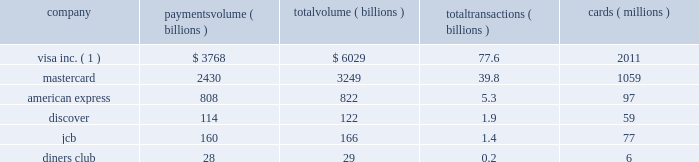As the payments landscape evolves , we may increasingly face competition from emerging players in the payment space , many of which are non-financial institution networks that have departed from the more traditional 201cbank-centric 201d business model .
The emergence of these potentially competitive networks has primarily been via the online channel with a focus on ecommerce and/or mobile technologies .
Paypal , google and isis are examples .
These providers compete with visa directly in some cases , yet may also be significant partners and customers of visa .
Based on payments volume , total volume and number of transactions , visa is the largest retail electronic payments network in the world .
The following chart compares our network with those of our major general purpose payment network competitors for calendar year 2011 : company payments volume volume transactions cards ( billions ) ( billions ) ( billions ) ( millions ) visa inc. ( 1 ) .
$ 3768 $ 6029 77.6 2011 .
( 1 ) visa inc .
Figures as reported on form 8-k filed with the sec on february 8 and may 2 , 2012 , respectively .
Visa figures represent total volume , payments volume and cash volume , and the number of payments transactions , cash transactions , accounts and cards for products carrying the visa , visa electron and interlink brands .
Card counts include plus proprietary cards .
Payments volume represents the aggregate dollar amount of purchases made with cards carrying the visa , visa electron and interlink brands for the relevant period .
Total volume represents payments volume plus cash volume .
The data presented is reported quarterly by visa 2019s clients on their operating certificates and is subject to verification by visa .
On occasion , clients may update previously submitted information .
Sources : mastercard , american express , jcb and diners club data sourced from the nilson report issue 992 ( april 2012 ) .
Includes all consumer and commercial credit , debit and prepaid cards .
Some prior year figures have been restated .
Currency figures are in u.s .
Dollars .
Mastercard excludes maestro and cirrus figures .
American express includes figures for third-party issuers .
Jcb figures include third-party issuers and other payment-related products .
Some figures are estimates .
Diners club figures are for the 12 months ended november 30 , 2011 .
Discover data sourced from the nilson report issue 986 ( january 2012 ) 2014u.s .
Data only and includes business from third-party issuers .
For more information on the concentration of our operating revenues and other financial information , see item 8 2014financial statements and supplementary data 2014note 14 2014enterprise-wide disclosures and concentration of business included elsewhere in this report .
Working capital requirements payments settlement due from and due to issuing and acquiring clients represents a substantial daily working capital requirement .
U.s .
Dollar settlements are typically settled within the same day and do not result in a receivable or payable balance , while settlement currencies other than the u.s .
Dollar generally remain outstanding for one to two business days , consistent with industry practice for such transactions. .
What is the average payment per transaction of discover holders? 
Computations: (114 / 1.9)
Answer: 60.0. 